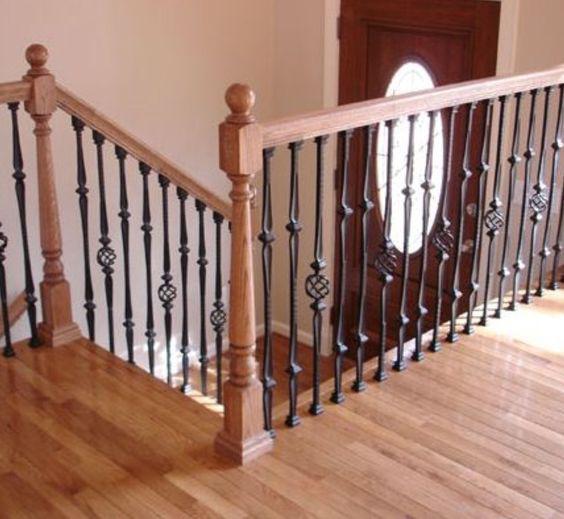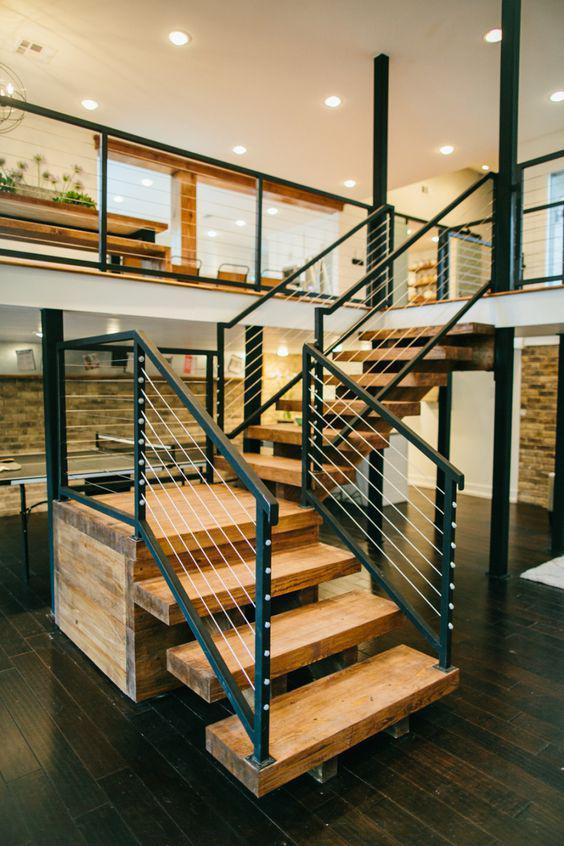The first image is the image on the left, the second image is the image on the right. Examine the images to the left and right. Is the description "There is one set of stairs that has no risers." accurate? Answer yes or no. Yes. 